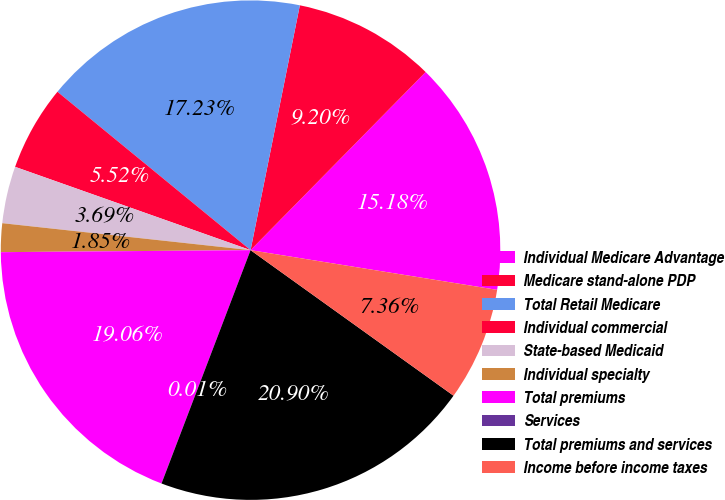Convert chart to OTSL. <chart><loc_0><loc_0><loc_500><loc_500><pie_chart><fcel>Individual Medicare Advantage<fcel>Medicare stand-alone PDP<fcel>Total Retail Medicare<fcel>Individual commercial<fcel>State-based Medicaid<fcel>Individual specialty<fcel>Total premiums<fcel>Services<fcel>Total premiums and services<fcel>Income before income taxes<nl><fcel>15.18%<fcel>9.2%<fcel>17.23%<fcel>5.52%<fcel>3.69%<fcel>1.85%<fcel>19.06%<fcel>0.01%<fcel>20.9%<fcel>7.36%<nl></chart> 